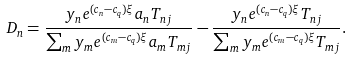Convert formula to latex. <formula><loc_0><loc_0><loc_500><loc_500>D _ { n } = \frac { y _ { n } e ^ { ( c _ { n } - c _ { q } ) \xi } a _ { n } T _ { n j } } { \sum _ { m } y _ { m } e ^ { ( c _ { m } - c _ { q } ) \xi } a _ { m } T _ { m j } } - \frac { y _ { n } e ^ { ( c _ { n } - c _ { q } ) \xi } T _ { n j } } { \sum _ { m } y _ { m } e ^ { ( c _ { m } - c _ { q } ) \xi } T _ { m j } } .</formula> 